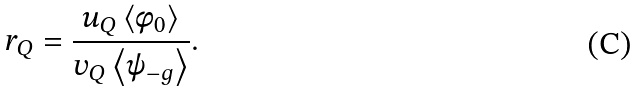<formula> <loc_0><loc_0><loc_500><loc_500>r _ { Q } = \frac { u _ { Q } \left < \phi _ { 0 } \right > } { v _ { Q } \left < \psi _ { - g } \right > } .</formula> 